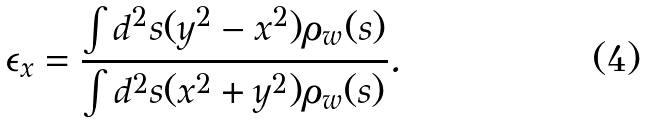<formula> <loc_0><loc_0><loc_500><loc_500>\epsilon _ { x } = \frac { \int { d ^ { 2 } s } ( y ^ { 2 } - x ^ { 2 } ) \rho _ { w } ( { s } ) } { \int { d ^ { 2 } s } ( x ^ { 2 } + y ^ { 2 } ) \rho _ { w } ( { s } ) } .</formula> 